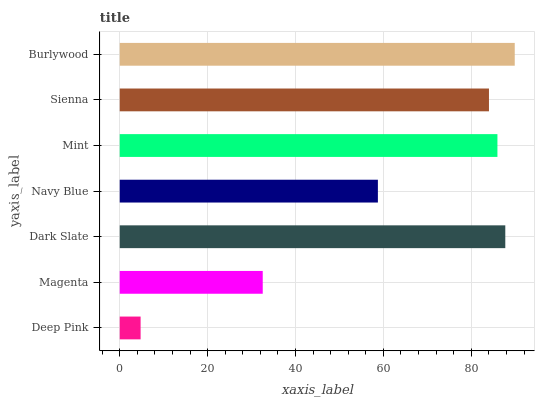Is Deep Pink the minimum?
Answer yes or no. Yes. Is Burlywood the maximum?
Answer yes or no. Yes. Is Magenta the minimum?
Answer yes or no. No. Is Magenta the maximum?
Answer yes or no. No. Is Magenta greater than Deep Pink?
Answer yes or no. Yes. Is Deep Pink less than Magenta?
Answer yes or no. Yes. Is Deep Pink greater than Magenta?
Answer yes or no. No. Is Magenta less than Deep Pink?
Answer yes or no. No. Is Sienna the high median?
Answer yes or no. Yes. Is Sienna the low median?
Answer yes or no. Yes. Is Deep Pink the high median?
Answer yes or no. No. Is Deep Pink the low median?
Answer yes or no. No. 